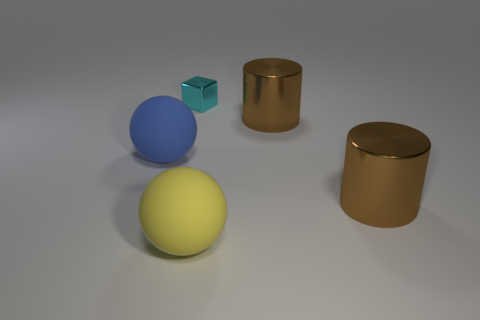Add 2 large yellow things. How many objects exist? 7 Subtract all spheres. How many objects are left? 3 Subtract all blue shiny cylinders. Subtract all yellow rubber balls. How many objects are left? 4 Add 3 yellow balls. How many yellow balls are left? 4 Add 4 big brown matte cubes. How many big brown matte cubes exist? 4 Subtract 0 red cubes. How many objects are left? 5 